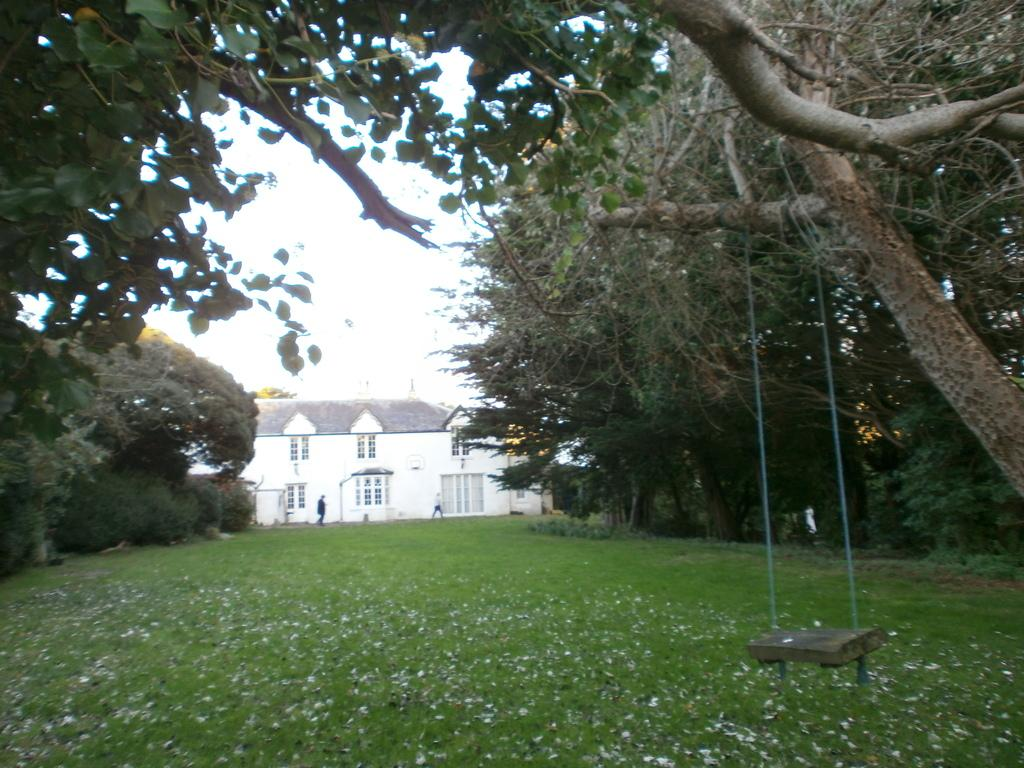What is the main object in the image? There is a swing in the image. What type of surface is beneath the swing? Grass is present in the image. What structure can be seen in the background? There is a house in the image. What type of vegetation is visible in the image? Trees are visible in the image. How many people are in the image? There are two persons in the image. What is visible in the background of the image? The sky is visible in the background of the image. What type of blood is visible on the swing in the image? There is no blood visible on the swing in the image. What type of business is being conducted on the swing in the image? There is no business being conducted on the swing in the image. 